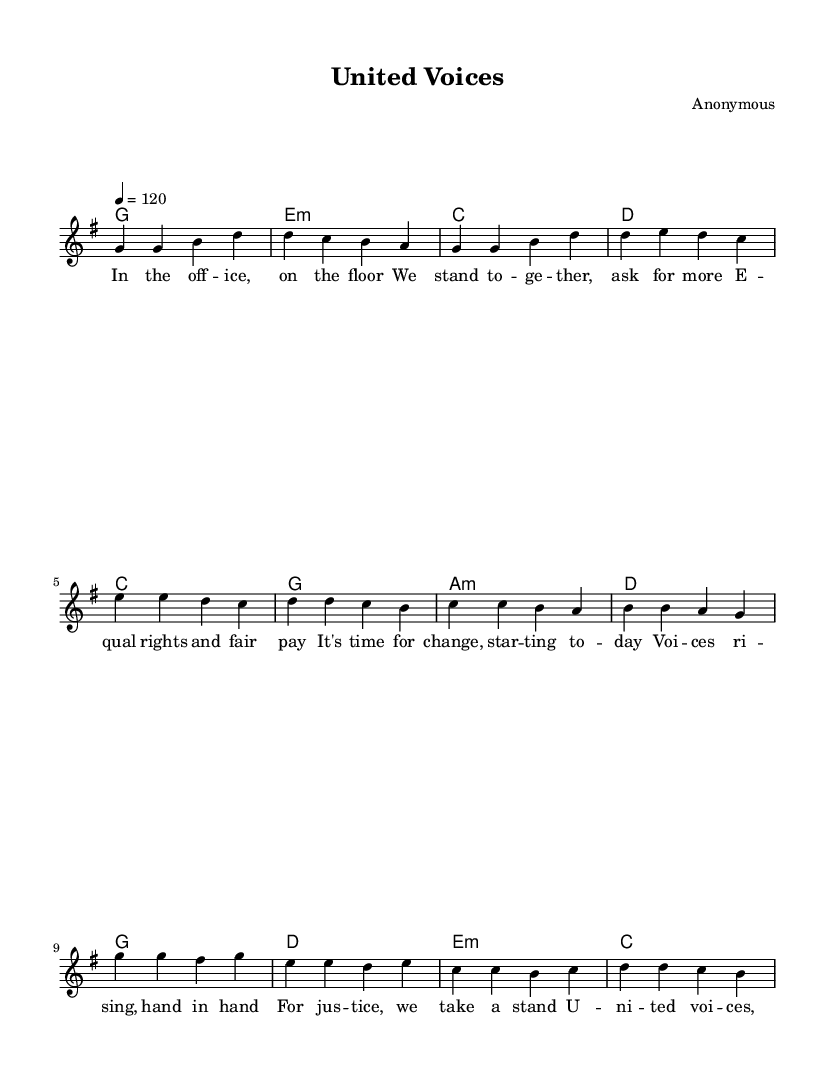What is the key signature of this music? The key signature is G major, which contains one sharp (F#). In the score, it is indicated at the beginning of the staff.
Answer: G major What is the time signature of this music? The time signature is 4/4, which means there are four beats in each measure and a quarter note receives one beat. This is indicated at the beginning of the score.
Answer: 4/4 What is the tempo marking for this piece? The tempo marking is 120 beats per minute, which dictates the speed at which the piece should be played. It is shown as a number at the beginning of the score.
Answer: 120 How many lines are in the staff? The staff consists of five lines. This is a standard characteristic of Western music notation, which is visible in the score.
Answer: Five Which section contains the lyrics "United voices, loud and clear"? This lyric is found in the chorus section, as it is specifically highlighted under the corresponding melody notes.
Answer: Chorus How many measures are in the verse section? There are four measures in the verse section of the music, as indicated by the grouping of notes and bars in that part.
Answer: Four What is the overall theme presented in the song's lyrics? The theme presented in the lyrics centers around workplace equality and fair treatment for all, highlighted by phrases emphasizing unity and justice.
Answer: Workplace equality 